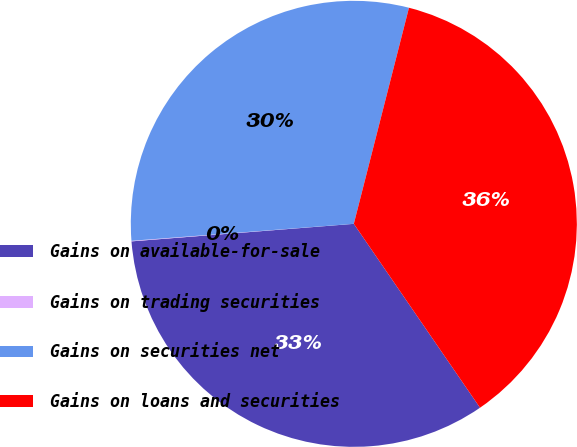Convert chart to OTSL. <chart><loc_0><loc_0><loc_500><loc_500><pie_chart><fcel>Gains on available-for-sale<fcel>Gains on trading securities<fcel>Gains on securities net<fcel>Gains on loans and securities<nl><fcel>33.32%<fcel>0.04%<fcel>30.19%<fcel>36.45%<nl></chart> 